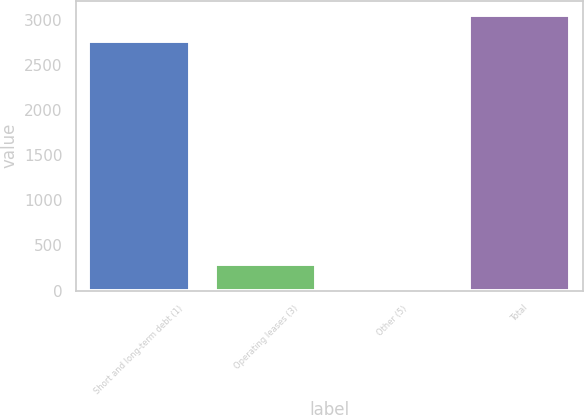Convert chart. <chart><loc_0><loc_0><loc_500><loc_500><bar_chart><fcel>Short and long-term debt (1)<fcel>Operating leases (3)<fcel>Other (5)<fcel>Total<nl><fcel>2767.8<fcel>289.15<fcel>1.5<fcel>3055.45<nl></chart> 